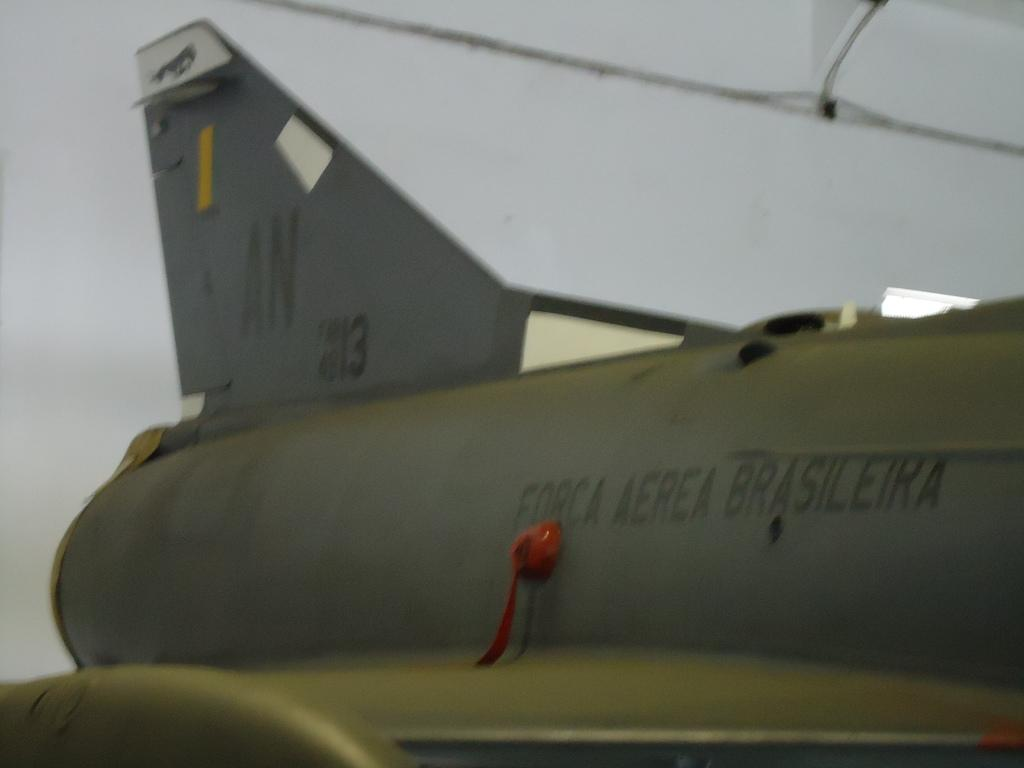Provide a one-sentence caption for the provided image. The tail of a plane labeled Forca Aerea Brasileira is zoomed in on. 